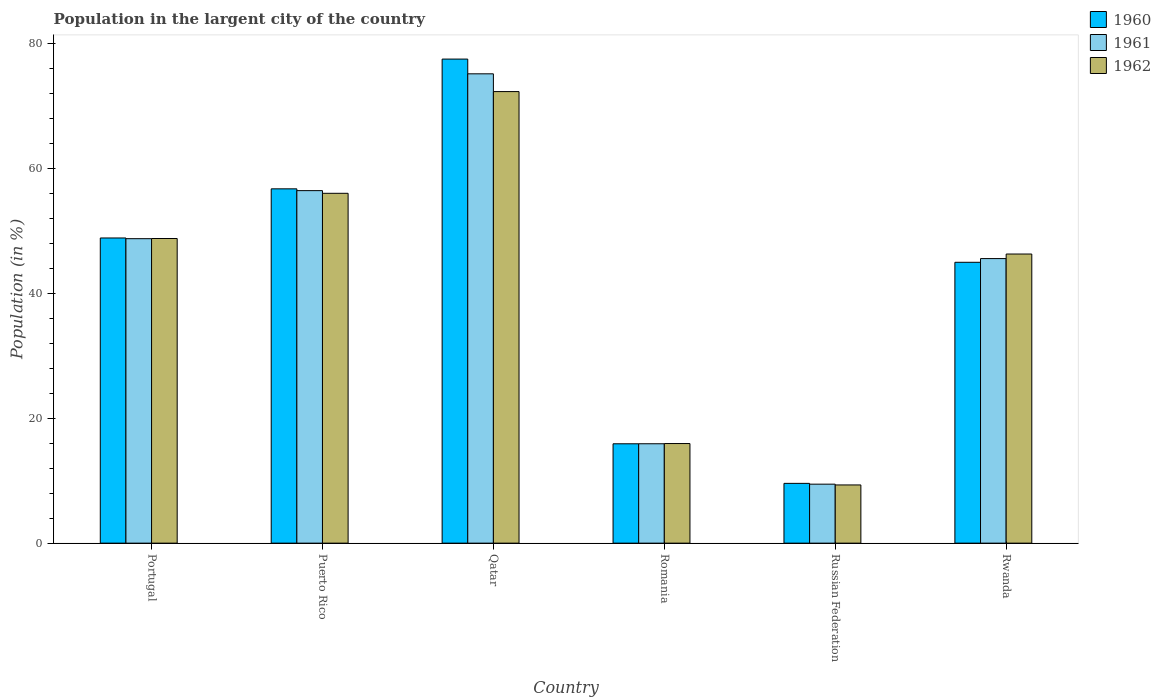What is the percentage of population in the largent city in 1960 in Romania?
Provide a succinct answer. 15.92. Across all countries, what is the maximum percentage of population in the largent city in 1961?
Your answer should be very brief. 75.19. Across all countries, what is the minimum percentage of population in the largent city in 1962?
Offer a terse response. 9.33. In which country was the percentage of population in the largent city in 1960 maximum?
Provide a succinct answer. Qatar. In which country was the percentage of population in the largent city in 1960 minimum?
Offer a very short reply. Russian Federation. What is the total percentage of population in the largent city in 1961 in the graph?
Provide a succinct answer. 251.41. What is the difference between the percentage of population in the largent city in 1960 in Qatar and that in Russian Federation?
Your response must be concise. 67.98. What is the difference between the percentage of population in the largent city in 1962 in Portugal and the percentage of population in the largent city in 1960 in Qatar?
Offer a very short reply. -28.75. What is the average percentage of population in the largent city in 1960 per country?
Your answer should be compact. 42.28. What is the difference between the percentage of population in the largent city of/in 1962 and percentage of population in the largent city of/in 1961 in Portugal?
Offer a terse response. 0.03. In how many countries, is the percentage of population in the largent city in 1962 greater than 48 %?
Provide a succinct answer. 3. What is the ratio of the percentage of population in the largent city in 1962 in Qatar to that in Rwanda?
Your answer should be very brief. 1.56. Is the percentage of population in the largent city in 1962 in Puerto Rico less than that in Qatar?
Your response must be concise. Yes. What is the difference between the highest and the second highest percentage of population in the largent city in 1960?
Your response must be concise. 7.87. What is the difference between the highest and the lowest percentage of population in the largent city in 1962?
Give a very brief answer. 63.02. Is it the case that in every country, the sum of the percentage of population in the largent city in 1960 and percentage of population in the largent city in 1961 is greater than the percentage of population in the largent city in 1962?
Keep it short and to the point. Yes. How many bars are there?
Ensure brevity in your answer.  18. Are the values on the major ticks of Y-axis written in scientific E-notation?
Offer a very short reply. No. Does the graph contain any zero values?
Offer a very short reply. No. How many legend labels are there?
Make the answer very short. 3. How are the legend labels stacked?
Provide a succinct answer. Vertical. What is the title of the graph?
Provide a succinct answer. Population in the largent city of the country. Does "1984" appear as one of the legend labels in the graph?
Make the answer very short. No. What is the Population (in %) in 1960 in Portugal?
Your answer should be compact. 48.89. What is the Population (in %) in 1961 in Portugal?
Ensure brevity in your answer.  48.78. What is the Population (in %) of 1962 in Portugal?
Give a very brief answer. 48.81. What is the Population (in %) of 1960 in Puerto Rico?
Give a very brief answer. 56.77. What is the Population (in %) of 1961 in Puerto Rico?
Provide a short and direct response. 56.48. What is the Population (in %) in 1962 in Puerto Rico?
Offer a very short reply. 56.05. What is the Population (in %) of 1960 in Qatar?
Your response must be concise. 77.55. What is the Population (in %) in 1961 in Qatar?
Ensure brevity in your answer.  75.19. What is the Population (in %) in 1962 in Qatar?
Provide a short and direct response. 72.35. What is the Population (in %) of 1960 in Romania?
Ensure brevity in your answer.  15.92. What is the Population (in %) in 1961 in Romania?
Provide a succinct answer. 15.92. What is the Population (in %) in 1962 in Romania?
Keep it short and to the point. 15.96. What is the Population (in %) in 1960 in Russian Federation?
Provide a succinct answer. 9.58. What is the Population (in %) of 1961 in Russian Federation?
Provide a short and direct response. 9.45. What is the Population (in %) in 1962 in Russian Federation?
Make the answer very short. 9.33. What is the Population (in %) in 1960 in Rwanda?
Your response must be concise. 45. What is the Population (in %) of 1961 in Rwanda?
Provide a short and direct response. 45.59. What is the Population (in %) of 1962 in Rwanda?
Provide a short and direct response. 46.32. Across all countries, what is the maximum Population (in %) in 1960?
Your answer should be compact. 77.55. Across all countries, what is the maximum Population (in %) of 1961?
Keep it short and to the point. 75.19. Across all countries, what is the maximum Population (in %) in 1962?
Give a very brief answer. 72.35. Across all countries, what is the minimum Population (in %) in 1960?
Your answer should be compact. 9.58. Across all countries, what is the minimum Population (in %) of 1961?
Provide a succinct answer. 9.45. Across all countries, what is the minimum Population (in %) of 1962?
Your answer should be very brief. 9.33. What is the total Population (in %) of 1960 in the graph?
Provide a succinct answer. 253.71. What is the total Population (in %) in 1961 in the graph?
Ensure brevity in your answer.  251.41. What is the total Population (in %) in 1962 in the graph?
Provide a succinct answer. 248.81. What is the difference between the Population (in %) in 1960 in Portugal and that in Puerto Rico?
Your response must be concise. -7.87. What is the difference between the Population (in %) in 1961 in Portugal and that in Puerto Rico?
Give a very brief answer. -7.7. What is the difference between the Population (in %) of 1962 in Portugal and that in Puerto Rico?
Your answer should be very brief. -7.24. What is the difference between the Population (in %) of 1960 in Portugal and that in Qatar?
Your response must be concise. -28.66. What is the difference between the Population (in %) in 1961 in Portugal and that in Qatar?
Ensure brevity in your answer.  -26.41. What is the difference between the Population (in %) of 1962 in Portugal and that in Qatar?
Your response must be concise. -23.54. What is the difference between the Population (in %) in 1960 in Portugal and that in Romania?
Your answer should be very brief. 32.98. What is the difference between the Population (in %) of 1961 in Portugal and that in Romania?
Provide a short and direct response. 32.86. What is the difference between the Population (in %) of 1962 in Portugal and that in Romania?
Keep it short and to the point. 32.85. What is the difference between the Population (in %) in 1960 in Portugal and that in Russian Federation?
Your answer should be very brief. 39.32. What is the difference between the Population (in %) of 1961 in Portugal and that in Russian Federation?
Offer a terse response. 39.33. What is the difference between the Population (in %) of 1962 in Portugal and that in Russian Federation?
Ensure brevity in your answer.  39.48. What is the difference between the Population (in %) of 1960 in Portugal and that in Rwanda?
Your answer should be very brief. 3.9. What is the difference between the Population (in %) in 1961 in Portugal and that in Rwanda?
Make the answer very short. 3.19. What is the difference between the Population (in %) of 1962 in Portugal and that in Rwanda?
Your answer should be compact. 2.48. What is the difference between the Population (in %) of 1960 in Puerto Rico and that in Qatar?
Your response must be concise. -20.79. What is the difference between the Population (in %) in 1961 in Puerto Rico and that in Qatar?
Give a very brief answer. -18.72. What is the difference between the Population (in %) in 1962 in Puerto Rico and that in Qatar?
Provide a succinct answer. -16.3. What is the difference between the Population (in %) of 1960 in Puerto Rico and that in Romania?
Your answer should be compact. 40.85. What is the difference between the Population (in %) in 1961 in Puerto Rico and that in Romania?
Give a very brief answer. 40.55. What is the difference between the Population (in %) of 1962 in Puerto Rico and that in Romania?
Offer a terse response. 40.09. What is the difference between the Population (in %) of 1960 in Puerto Rico and that in Russian Federation?
Keep it short and to the point. 47.19. What is the difference between the Population (in %) in 1961 in Puerto Rico and that in Russian Federation?
Provide a short and direct response. 47.03. What is the difference between the Population (in %) in 1962 in Puerto Rico and that in Russian Federation?
Your answer should be very brief. 46.73. What is the difference between the Population (in %) in 1960 in Puerto Rico and that in Rwanda?
Your answer should be very brief. 11.77. What is the difference between the Population (in %) in 1961 in Puerto Rico and that in Rwanda?
Provide a short and direct response. 10.89. What is the difference between the Population (in %) of 1962 in Puerto Rico and that in Rwanda?
Your response must be concise. 9.73. What is the difference between the Population (in %) of 1960 in Qatar and that in Romania?
Keep it short and to the point. 61.64. What is the difference between the Population (in %) of 1961 in Qatar and that in Romania?
Your response must be concise. 59.27. What is the difference between the Population (in %) of 1962 in Qatar and that in Romania?
Your answer should be very brief. 56.39. What is the difference between the Population (in %) of 1960 in Qatar and that in Russian Federation?
Provide a succinct answer. 67.98. What is the difference between the Population (in %) in 1961 in Qatar and that in Russian Federation?
Make the answer very short. 65.74. What is the difference between the Population (in %) in 1962 in Qatar and that in Russian Federation?
Provide a short and direct response. 63.02. What is the difference between the Population (in %) in 1960 in Qatar and that in Rwanda?
Make the answer very short. 32.56. What is the difference between the Population (in %) in 1961 in Qatar and that in Rwanda?
Your answer should be very brief. 29.6. What is the difference between the Population (in %) in 1962 in Qatar and that in Rwanda?
Provide a short and direct response. 26.02. What is the difference between the Population (in %) in 1960 in Romania and that in Russian Federation?
Give a very brief answer. 6.34. What is the difference between the Population (in %) in 1961 in Romania and that in Russian Federation?
Ensure brevity in your answer.  6.47. What is the difference between the Population (in %) of 1962 in Romania and that in Russian Federation?
Offer a very short reply. 6.63. What is the difference between the Population (in %) of 1960 in Romania and that in Rwanda?
Your response must be concise. -29.08. What is the difference between the Population (in %) in 1961 in Romania and that in Rwanda?
Provide a short and direct response. -29.67. What is the difference between the Population (in %) in 1962 in Romania and that in Rwanda?
Offer a very short reply. -30.36. What is the difference between the Population (in %) in 1960 in Russian Federation and that in Rwanda?
Ensure brevity in your answer.  -35.42. What is the difference between the Population (in %) in 1961 in Russian Federation and that in Rwanda?
Give a very brief answer. -36.14. What is the difference between the Population (in %) in 1962 in Russian Federation and that in Rwanda?
Offer a terse response. -37. What is the difference between the Population (in %) of 1960 in Portugal and the Population (in %) of 1961 in Puerto Rico?
Your answer should be very brief. -7.58. What is the difference between the Population (in %) of 1960 in Portugal and the Population (in %) of 1962 in Puerto Rico?
Ensure brevity in your answer.  -7.16. What is the difference between the Population (in %) of 1961 in Portugal and the Population (in %) of 1962 in Puerto Rico?
Offer a very short reply. -7.27. What is the difference between the Population (in %) of 1960 in Portugal and the Population (in %) of 1961 in Qatar?
Offer a very short reply. -26.3. What is the difference between the Population (in %) in 1960 in Portugal and the Population (in %) in 1962 in Qatar?
Keep it short and to the point. -23.45. What is the difference between the Population (in %) in 1961 in Portugal and the Population (in %) in 1962 in Qatar?
Give a very brief answer. -23.57. What is the difference between the Population (in %) of 1960 in Portugal and the Population (in %) of 1961 in Romania?
Make the answer very short. 32.97. What is the difference between the Population (in %) of 1960 in Portugal and the Population (in %) of 1962 in Romania?
Provide a short and direct response. 32.94. What is the difference between the Population (in %) in 1961 in Portugal and the Population (in %) in 1962 in Romania?
Offer a very short reply. 32.82. What is the difference between the Population (in %) in 1960 in Portugal and the Population (in %) in 1961 in Russian Federation?
Offer a very short reply. 39.44. What is the difference between the Population (in %) in 1960 in Portugal and the Population (in %) in 1962 in Russian Federation?
Offer a terse response. 39.57. What is the difference between the Population (in %) of 1961 in Portugal and the Population (in %) of 1962 in Russian Federation?
Keep it short and to the point. 39.46. What is the difference between the Population (in %) of 1960 in Portugal and the Population (in %) of 1961 in Rwanda?
Make the answer very short. 3.3. What is the difference between the Population (in %) of 1960 in Portugal and the Population (in %) of 1962 in Rwanda?
Your response must be concise. 2.57. What is the difference between the Population (in %) of 1961 in Portugal and the Population (in %) of 1962 in Rwanda?
Give a very brief answer. 2.46. What is the difference between the Population (in %) in 1960 in Puerto Rico and the Population (in %) in 1961 in Qatar?
Offer a very short reply. -18.43. What is the difference between the Population (in %) of 1960 in Puerto Rico and the Population (in %) of 1962 in Qatar?
Give a very brief answer. -15.58. What is the difference between the Population (in %) of 1961 in Puerto Rico and the Population (in %) of 1962 in Qatar?
Provide a short and direct response. -15.87. What is the difference between the Population (in %) in 1960 in Puerto Rico and the Population (in %) in 1961 in Romania?
Offer a terse response. 40.84. What is the difference between the Population (in %) in 1960 in Puerto Rico and the Population (in %) in 1962 in Romania?
Your answer should be compact. 40.81. What is the difference between the Population (in %) in 1961 in Puerto Rico and the Population (in %) in 1962 in Romania?
Provide a succinct answer. 40.52. What is the difference between the Population (in %) of 1960 in Puerto Rico and the Population (in %) of 1961 in Russian Federation?
Offer a very short reply. 47.32. What is the difference between the Population (in %) in 1960 in Puerto Rico and the Population (in %) in 1962 in Russian Federation?
Ensure brevity in your answer.  47.44. What is the difference between the Population (in %) of 1961 in Puerto Rico and the Population (in %) of 1962 in Russian Federation?
Provide a short and direct response. 47.15. What is the difference between the Population (in %) of 1960 in Puerto Rico and the Population (in %) of 1961 in Rwanda?
Keep it short and to the point. 11.18. What is the difference between the Population (in %) of 1960 in Puerto Rico and the Population (in %) of 1962 in Rwanda?
Your response must be concise. 10.44. What is the difference between the Population (in %) of 1961 in Puerto Rico and the Population (in %) of 1962 in Rwanda?
Offer a terse response. 10.16. What is the difference between the Population (in %) of 1960 in Qatar and the Population (in %) of 1961 in Romania?
Provide a short and direct response. 61.63. What is the difference between the Population (in %) in 1960 in Qatar and the Population (in %) in 1962 in Romania?
Offer a terse response. 61.6. What is the difference between the Population (in %) of 1961 in Qatar and the Population (in %) of 1962 in Romania?
Provide a short and direct response. 59.24. What is the difference between the Population (in %) of 1960 in Qatar and the Population (in %) of 1961 in Russian Federation?
Your answer should be compact. 68.11. What is the difference between the Population (in %) in 1960 in Qatar and the Population (in %) in 1962 in Russian Federation?
Keep it short and to the point. 68.23. What is the difference between the Population (in %) of 1961 in Qatar and the Population (in %) of 1962 in Russian Federation?
Your answer should be very brief. 65.87. What is the difference between the Population (in %) in 1960 in Qatar and the Population (in %) in 1961 in Rwanda?
Your answer should be very brief. 31.97. What is the difference between the Population (in %) in 1960 in Qatar and the Population (in %) in 1962 in Rwanda?
Ensure brevity in your answer.  31.23. What is the difference between the Population (in %) in 1961 in Qatar and the Population (in %) in 1962 in Rwanda?
Ensure brevity in your answer.  28.87. What is the difference between the Population (in %) of 1960 in Romania and the Population (in %) of 1961 in Russian Federation?
Your answer should be compact. 6.47. What is the difference between the Population (in %) of 1960 in Romania and the Population (in %) of 1962 in Russian Federation?
Offer a terse response. 6.59. What is the difference between the Population (in %) of 1961 in Romania and the Population (in %) of 1962 in Russian Federation?
Your answer should be very brief. 6.6. What is the difference between the Population (in %) of 1960 in Romania and the Population (in %) of 1961 in Rwanda?
Your answer should be very brief. -29.67. What is the difference between the Population (in %) in 1960 in Romania and the Population (in %) in 1962 in Rwanda?
Provide a succinct answer. -30.4. What is the difference between the Population (in %) of 1961 in Romania and the Population (in %) of 1962 in Rwanda?
Ensure brevity in your answer.  -30.4. What is the difference between the Population (in %) of 1960 in Russian Federation and the Population (in %) of 1961 in Rwanda?
Keep it short and to the point. -36.01. What is the difference between the Population (in %) of 1960 in Russian Federation and the Population (in %) of 1962 in Rwanda?
Offer a terse response. -36.74. What is the difference between the Population (in %) of 1961 in Russian Federation and the Population (in %) of 1962 in Rwanda?
Your answer should be very brief. -36.87. What is the average Population (in %) of 1960 per country?
Provide a succinct answer. 42.28. What is the average Population (in %) of 1961 per country?
Your answer should be compact. 41.9. What is the average Population (in %) in 1962 per country?
Your response must be concise. 41.47. What is the difference between the Population (in %) of 1960 and Population (in %) of 1961 in Portugal?
Make the answer very short. 0.11. What is the difference between the Population (in %) of 1960 and Population (in %) of 1962 in Portugal?
Offer a terse response. 0.09. What is the difference between the Population (in %) in 1961 and Population (in %) in 1962 in Portugal?
Offer a terse response. -0.03. What is the difference between the Population (in %) in 1960 and Population (in %) in 1961 in Puerto Rico?
Your response must be concise. 0.29. What is the difference between the Population (in %) of 1960 and Population (in %) of 1962 in Puerto Rico?
Your response must be concise. 0.71. What is the difference between the Population (in %) in 1961 and Population (in %) in 1962 in Puerto Rico?
Your response must be concise. 0.43. What is the difference between the Population (in %) of 1960 and Population (in %) of 1961 in Qatar?
Provide a succinct answer. 2.36. What is the difference between the Population (in %) in 1960 and Population (in %) in 1962 in Qatar?
Your answer should be very brief. 5.21. What is the difference between the Population (in %) of 1961 and Population (in %) of 1962 in Qatar?
Your response must be concise. 2.85. What is the difference between the Population (in %) of 1960 and Population (in %) of 1961 in Romania?
Make the answer very short. -0.01. What is the difference between the Population (in %) of 1960 and Population (in %) of 1962 in Romania?
Your response must be concise. -0.04. What is the difference between the Population (in %) in 1961 and Population (in %) in 1962 in Romania?
Ensure brevity in your answer.  -0.03. What is the difference between the Population (in %) in 1960 and Population (in %) in 1961 in Russian Federation?
Provide a short and direct response. 0.13. What is the difference between the Population (in %) in 1960 and Population (in %) in 1962 in Russian Federation?
Your answer should be very brief. 0.25. What is the difference between the Population (in %) of 1961 and Population (in %) of 1962 in Russian Federation?
Give a very brief answer. 0.12. What is the difference between the Population (in %) in 1960 and Population (in %) in 1961 in Rwanda?
Keep it short and to the point. -0.59. What is the difference between the Population (in %) of 1960 and Population (in %) of 1962 in Rwanda?
Your answer should be very brief. -1.32. What is the difference between the Population (in %) in 1961 and Population (in %) in 1962 in Rwanda?
Your response must be concise. -0.73. What is the ratio of the Population (in %) of 1960 in Portugal to that in Puerto Rico?
Give a very brief answer. 0.86. What is the ratio of the Population (in %) of 1961 in Portugal to that in Puerto Rico?
Your response must be concise. 0.86. What is the ratio of the Population (in %) of 1962 in Portugal to that in Puerto Rico?
Provide a short and direct response. 0.87. What is the ratio of the Population (in %) in 1960 in Portugal to that in Qatar?
Provide a short and direct response. 0.63. What is the ratio of the Population (in %) in 1961 in Portugal to that in Qatar?
Provide a short and direct response. 0.65. What is the ratio of the Population (in %) of 1962 in Portugal to that in Qatar?
Your answer should be very brief. 0.67. What is the ratio of the Population (in %) of 1960 in Portugal to that in Romania?
Provide a short and direct response. 3.07. What is the ratio of the Population (in %) of 1961 in Portugal to that in Romania?
Offer a terse response. 3.06. What is the ratio of the Population (in %) in 1962 in Portugal to that in Romania?
Your answer should be compact. 3.06. What is the ratio of the Population (in %) of 1960 in Portugal to that in Russian Federation?
Provide a succinct answer. 5.11. What is the ratio of the Population (in %) in 1961 in Portugal to that in Russian Federation?
Your response must be concise. 5.16. What is the ratio of the Population (in %) of 1962 in Portugal to that in Russian Federation?
Your response must be concise. 5.23. What is the ratio of the Population (in %) of 1960 in Portugal to that in Rwanda?
Ensure brevity in your answer.  1.09. What is the ratio of the Population (in %) in 1961 in Portugal to that in Rwanda?
Provide a succinct answer. 1.07. What is the ratio of the Population (in %) of 1962 in Portugal to that in Rwanda?
Provide a short and direct response. 1.05. What is the ratio of the Population (in %) of 1960 in Puerto Rico to that in Qatar?
Your answer should be very brief. 0.73. What is the ratio of the Population (in %) of 1961 in Puerto Rico to that in Qatar?
Your answer should be very brief. 0.75. What is the ratio of the Population (in %) of 1962 in Puerto Rico to that in Qatar?
Offer a terse response. 0.77. What is the ratio of the Population (in %) in 1960 in Puerto Rico to that in Romania?
Your answer should be compact. 3.57. What is the ratio of the Population (in %) in 1961 in Puerto Rico to that in Romania?
Offer a terse response. 3.55. What is the ratio of the Population (in %) of 1962 in Puerto Rico to that in Romania?
Offer a terse response. 3.51. What is the ratio of the Population (in %) in 1960 in Puerto Rico to that in Russian Federation?
Ensure brevity in your answer.  5.93. What is the ratio of the Population (in %) in 1961 in Puerto Rico to that in Russian Federation?
Give a very brief answer. 5.98. What is the ratio of the Population (in %) in 1962 in Puerto Rico to that in Russian Federation?
Ensure brevity in your answer.  6.01. What is the ratio of the Population (in %) of 1960 in Puerto Rico to that in Rwanda?
Provide a succinct answer. 1.26. What is the ratio of the Population (in %) of 1961 in Puerto Rico to that in Rwanda?
Keep it short and to the point. 1.24. What is the ratio of the Population (in %) of 1962 in Puerto Rico to that in Rwanda?
Ensure brevity in your answer.  1.21. What is the ratio of the Population (in %) of 1960 in Qatar to that in Romania?
Your response must be concise. 4.87. What is the ratio of the Population (in %) in 1961 in Qatar to that in Romania?
Offer a very short reply. 4.72. What is the ratio of the Population (in %) in 1962 in Qatar to that in Romania?
Your answer should be very brief. 4.53. What is the ratio of the Population (in %) in 1960 in Qatar to that in Russian Federation?
Make the answer very short. 8.1. What is the ratio of the Population (in %) in 1961 in Qatar to that in Russian Federation?
Offer a very short reply. 7.96. What is the ratio of the Population (in %) in 1962 in Qatar to that in Russian Federation?
Keep it short and to the point. 7.76. What is the ratio of the Population (in %) in 1960 in Qatar to that in Rwanda?
Your response must be concise. 1.72. What is the ratio of the Population (in %) of 1961 in Qatar to that in Rwanda?
Ensure brevity in your answer.  1.65. What is the ratio of the Population (in %) of 1962 in Qatar to that in Rwanda?
Your response must be concise. 1.56. What is the ratio of the Population (in %) in 1960 in Romania to that in Russian Federation?
Your response must be concise. 1.66. What is the ratio of the Population (in %) in 1961 in Romania to that in Russian Federation?
Ensure brevity in your answer.  1.69. What is the ratio of the Population (in %) of 1962 in Romania to that in Russian Federation?
Your answer should be very brief. 1.71. What is the ratio of the Population (in %) in 1960 in Romania to that in Rwanda?
Offer a terse response. 0.35. What is the ratio of the Population (in %) of 1961 in Romania to that in Rwanda?
Your answer should be compact. 0.35. What is the ratio of the Population (in %) of 1962 in Romania to that in Rwanda?
Offer a very short reply. 0.34. What is the ratio of the Population (in %) of 1960 in Russian Federation to that in Rwanda?
Your response must be concise. 0.21. What is the ratio of the Population (in %) in 1961 in Russian Federation to that in Rwanda?
Give a very brief answer. 0.21. What is the ratio of the Population (in %) in 1962 in Russian Federation to that in Rwanda?
Offer a very short reply. 0.2. What is the difference between the highest and the second highest Population (in %) of 1960?
Ensure brevity in your answer.  20.79. What is the difference between the highest and the second highest Population (in %) in 1961?
Make the answer very short. 18.72. What is the difference between the highest and the second highest Population (in %) in 1962?
Ensure brevity in your answer.  16.3. What is the difference between the highest and the lowest Population (in %) in 1960?
Provide a short and direct response. 67.98. What is the difference between the highest and the lowest Population (in %) of 1961?
Give a very brief answer. 65.74. What is the difference between the highest and the lowest Population (in %) of 1962?
Offer a very short reply. 63.02. 